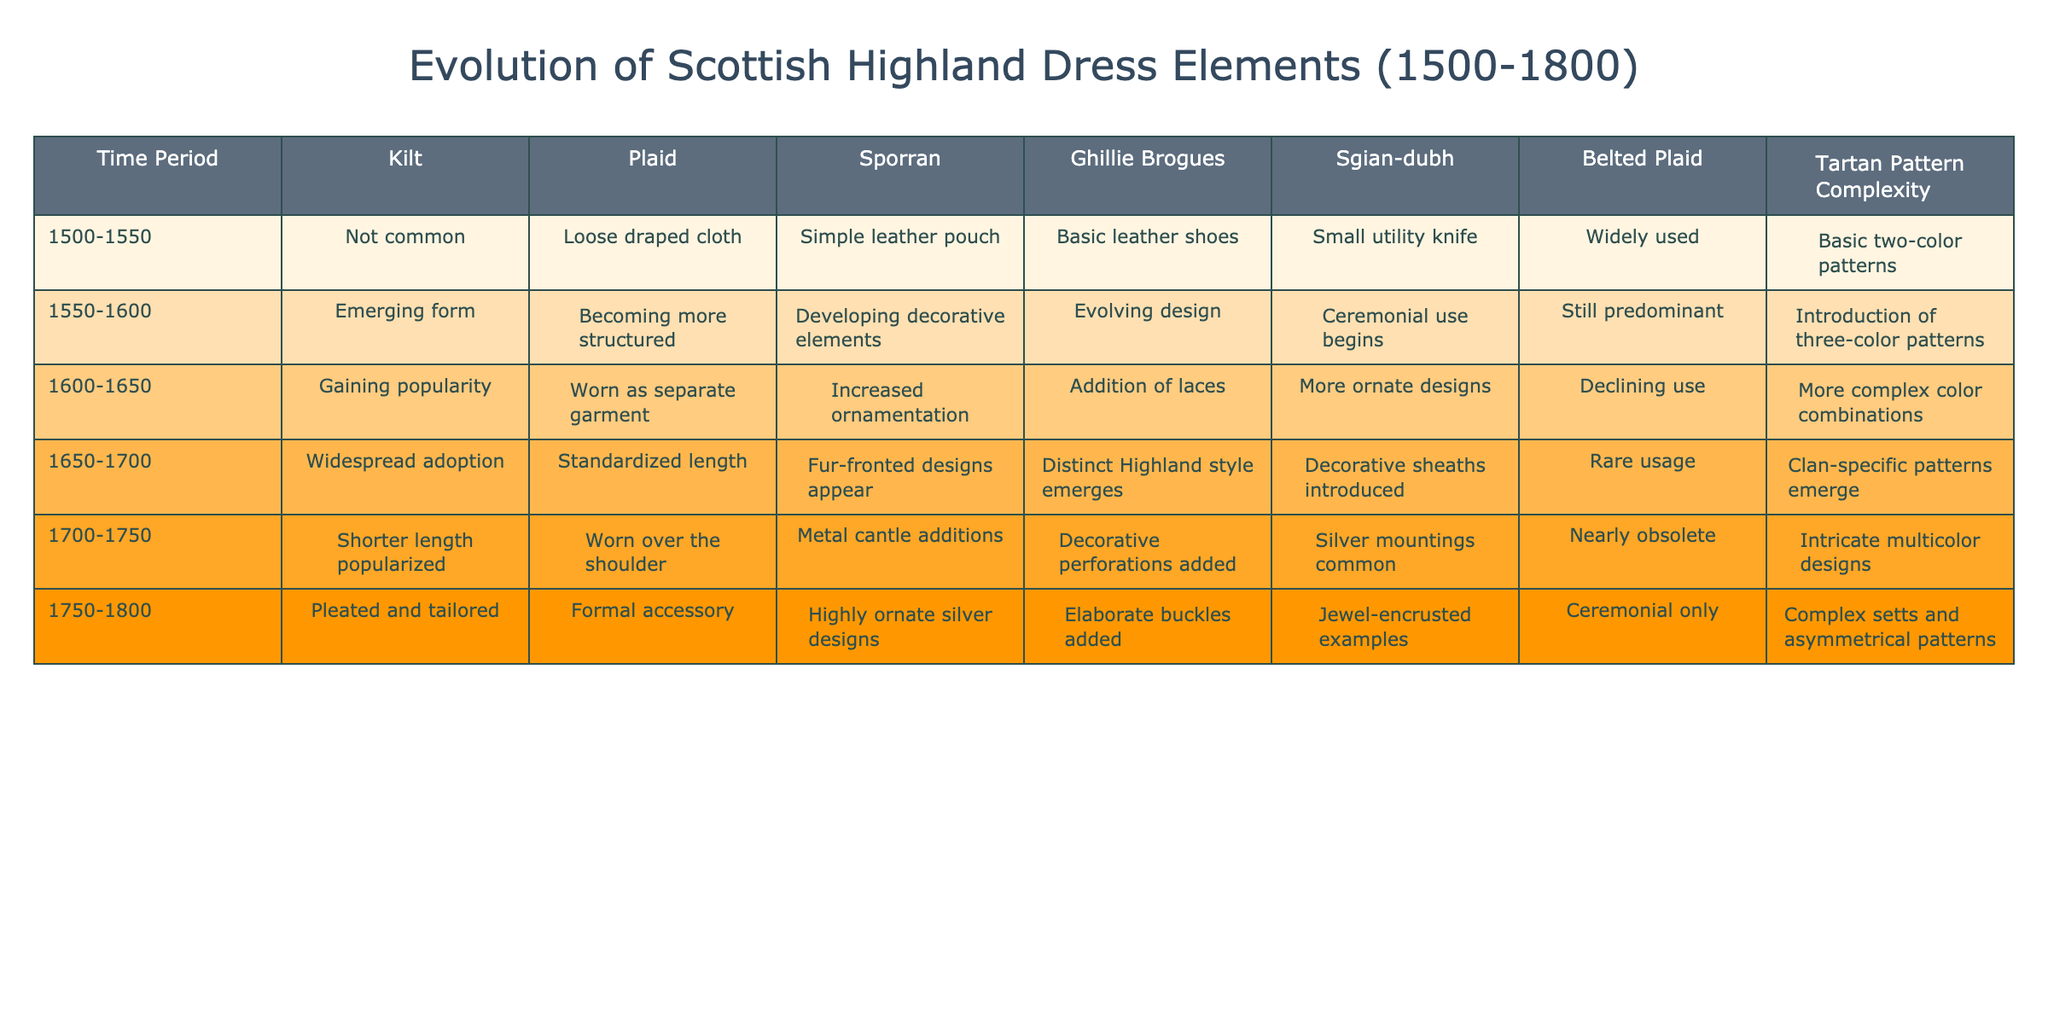What is the primary style of kilt during the period of 1500-1550? The table indicates that the kilt was not common during this period, which is reflected in the corresponding cell under the kilt column for 1500-1550.
Answer: Not common During which period did the use of the sporran develop decorative elements? According to the table, the sporran began to develop decorative elements between 1550 and 1600, as stated in the sporran column for that time period.
Answer: 1550-1600 What is the trend in complexity of tartan patterns from 1500 to 1800? The table shows a gradual increase in complexity of tartan patterns, starting with basic two-color patterns in 1500-1550 and leading to complex setts and asymmetrical patterns by 1750-1800.
Answer: Increasing complexity Which elements were nearly obsolete by 1700-1750? By looking at the table, we can see that the belted plaid became nearly obsolete during the 1700-1750 period as indicated in the respective cell.
Answer: Belted plaid Which time period shows the highest ornamentation in sporrans? The table indicates that between 1750 and 1800, sporrans were highly ornate with silver designs, which is in contrast to previous periods where ornamentation was less prominent.
Answer: 1750-1800 Did the use of the Ghillie Brogues become more intricate over time? Reviewing the Ghillie Brogues column, we see an evolution from basic leather shoes in 1500-1550 to elaborate buckles added in 1750-1800, suggesting an increase in intricacy.
Answer: Yes What was the most complex form of tartan seen in the late 18th century? The table indicates that by 1750-1800, tartan patterns were complex with setts and asymmetrical designs, showcasing a significant development compared to earlier periods.
Answer: Complex setts and asymmetrical patterns In which period did clan-specific patterns for tartans emerge? Based on the data, clan-specific patterns for tartans began to emerge between 1650 and 1700 as noted in the tartan pattern complexity column for that time.
Answer: 1650-1700 What are the key differences in Kilt style from 1600 to 1750? The table highlights a transition from a gaining popularity in kilt style from 1600-1650 to shorter lengths being popularized by 1700-1750, indicating a shift in design.
Answer: From gaining popularity to shorter length How many elements are ornate by the end of the 18th century? By examining the table, it is evident that the decorative elements such as sporran and Ghillie Brogues became highly ornate with silver and elaborate buckles respectively by 1750-1800, along with complex tartans.
Answer: Three elements become ornate 